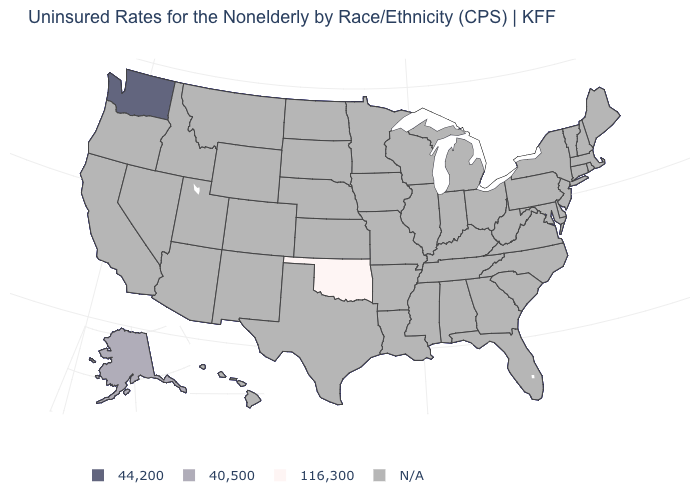Does Washington have the highest value in the USA?
Short answer required. Yes. How many symbols are there in the legend?
Give a very brief answer. 4. What is the value of Ohio?
Quick response, please. N/A. Which states hav the highest value in the West?
Answer briefly. Washington. Does the first symbol in the legend represent the smallest category?
Answer briefly. No. Which states have the highest value in the USA?
Give a very brief answer. Washington. Does Alaska have the lowest value in the USA?
Short answer required. No. Which states have the highest value in the USA?
Write a very short answer. Washington. Name the states that have a value in the range 44,200?
Quick response, please. Washington. Name the states that have a value in the range 44,200?
Answer briefly. Washington. Name the states that have a value in the range 40,500?
Concise answer only. Alaska. What is the value of South Dakota?
Short answer required. N/A. Name the states that have a value in the range 116,300?
Concise answer only. Oklahoma. 